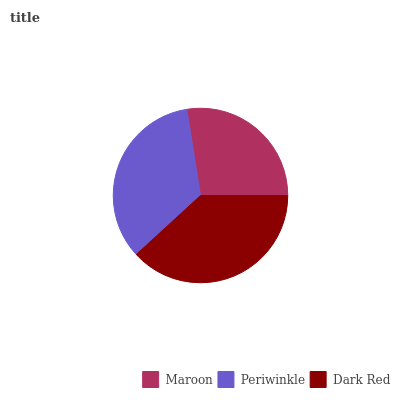Is Maroon the minimum?
Answer yes or no. Yes. Is Dark Red the maximum?
Answer yes or no. Yes. Is Periwinkle the minimum?
Answer yes or no. No. Is Periwinkle the maximum?
Answer yes or no. No. Is Periwinkle greater than Maroon?
Answer yes or no. Yes. Is Maroon less than Periwinkle?
Answer yes or no. Yes. Is Maroon greater than Periwinkle?
Answer yes or no. No. Is Periwinkle less than Maroon?
Answer yes or no. No. Is Periwinkle the high median?
Answer yes or no. Yes. Is Periwinkle the low median?
Answer yes or no. Yes. Is Maroon the high median?
Answer yes or no. No. Is Dark Red the low median?
Answer yes or no. No. 